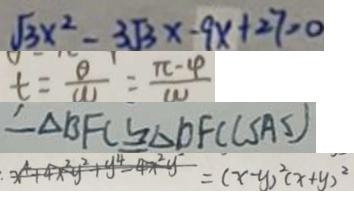<formula> <loc_0><loc_0><loc_500><loc_500>\sqrt { 3 } x ^ { 2 } - 3 \sqrt { 3 } x - 9 x + 2 7 = 0 
 t = \frac { \theta } { 1 1 } = \frac { \pi - 4 } { 1 1 } 
 \therefore \Delta B F C \cong \Delta D F C ( S A S ) 
 x ^ { 4 } + 4 x ^ { 2 } y ^ { 2 } + y ^ { 4 } - 4 x ^ { 2 } y ^ { 2 } = ( x - y ) ^ { 2 } ( x + y ) ^ { 2 }</formula> 